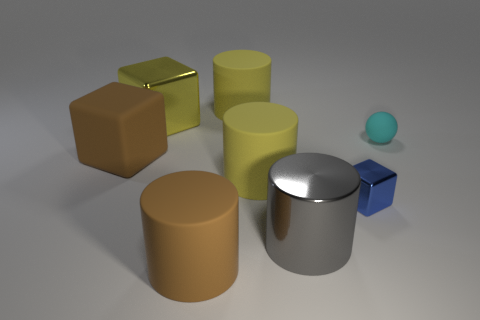How many cylinders are behind the tiny blue block and in front of the big brown matte block?
Your answer should be compact. 1. There is a shiny cube on the right side of the large brown object that is in front of the small shiny block; what size is it?
Make the answer very short. Small. Is the number of big brown rubber cylinders in front of the brown cylinder less than the number of big rubber cylinders on the left side of the large metal block?
Make the answer very short. No. Is the color of the matte cylinder in front of the blue shiny cube the same as the block left of the yellow cube?
Offer a very short reply. Yes. There is a cube that is right of the large matte cube and in front of the large yellow block; what is it made of?
Offer a terse response. Metal. Are there any cylinders?
Offer a very short reply. Yes. There is a big yellow object that is made of the same material as the small blue object; what is its shape?
Your answer should be very brief. Cube. There is a gray metallic thing; is it the same shape as the large brown matte thing that is in front of the gray metal cylinder?
Make the answer very short. Yes. There is a yellow object that is on the left side of the rubber cylinder that is in front of the small blue metal block; what is it made of?
Offer a terse response. Metal. How many other things are the same shape as the large gray shiny object?
Offer a terse response. 3. 